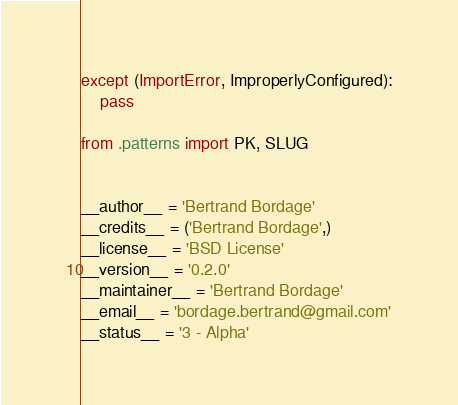Convert code to text. <code><loc_0><loc_0><loc_500><loc_500><_Python_>except (ImportError, ImproperlyConfigured):
    pass

from .patterns import PK, SLUG


__author__ = 'Bertrand Bordage'
__credits__ = ('Bertrand Bordage',)
__license__ = 'BSD License'
__version__ = '0.2.0'
__maintainer__ = 'Bertrand Bordage'
__email__ = 'bordage.bertrand@gmail.com'
__status__ = '3 - Alpha'
</code> 